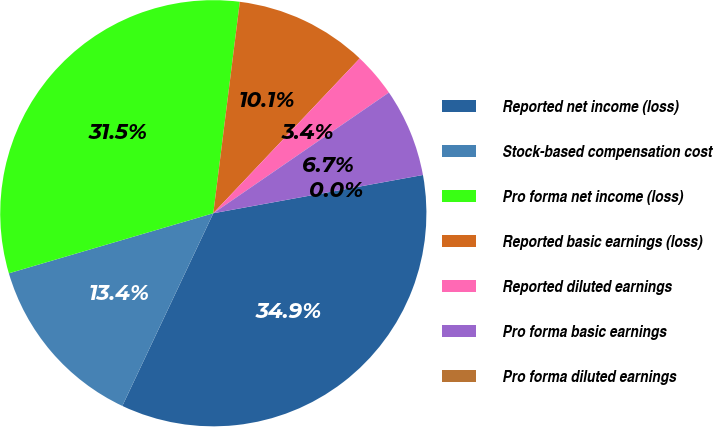Convert chart. <chart><loc_0><loc_0><loc_500><loc_500><pie_chart><fcel>Reported net income (loss)<fcel>Stock-based compensation cost<fcel>Pro forma net income (loss)<fcel>Reported basic earnings (loss)<fcel>Reported diluted earnings<fcel>Pro forma basic earnings<fcel>Pro forma diluted earnings<nl><fcel>34.89%<fcel>13.43%<fcel>31.53%<fcel>10.07%<fcel>3.36%<fcel>6.71%<fcel>0.0%<nl></chart> 